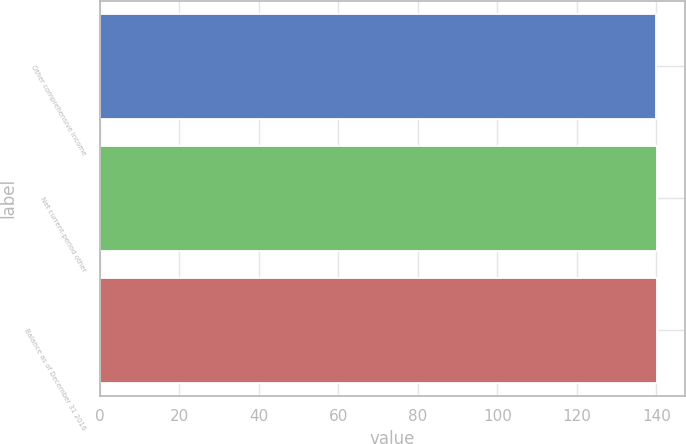<chart> <loc_0><loc_0><loc_500><loc_500><bar_chart><fcel>Other comprehensive income<fcel>Net current-period other<fcel>Balance as of December 31 2016<nl><fcel>140<fcel>140.1<fcel>140.2<nl></chart> 